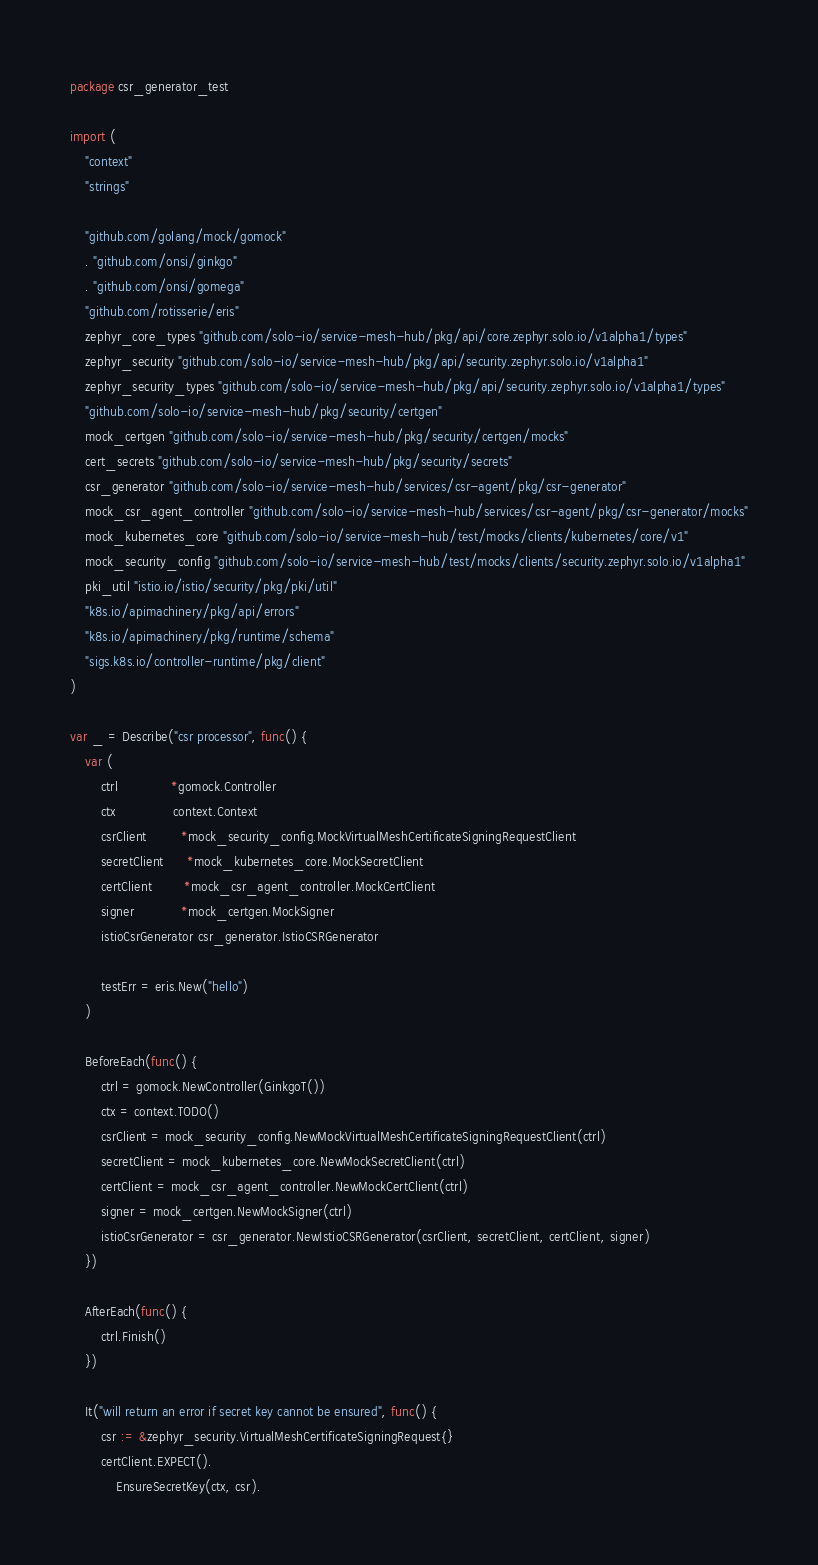Convert code to text. <code><loc_0><loc_0><loc_500><loc_500><_Go_>package csr_generator_test

import (
	"context"
	"strings"

	"github.com/golang/mock/gomock"
	. "github.com/onsi/ginkgo"
	. "github.com/onsi/gomega"
	"github.com/rotisserie/eris"
	zephyr_core_types "github.com/solo-io/service-mesh-hub/pkg/api/core.zephyr.solo.io/v1alpha1/types"
	zephyr_security "github.com/solo-io/service-mesh-hub/pkg/api/security.zephyr.solo.io/v1alpha1"
	zephyr_security_types "github.com/solo-io/service-mesh-hub/pkg/api/security.zephyr.solo.io/v1alpha1/types"
	"github.com/solo-io/service-mesh-hub/pkg/security/certgen"
	mock_certgen "github.com/solo-io/service-mesh-hub/pkg/security/certgen/mocks"
	cert_secrets "github.com/solo-io/service-mesh-hub/pkg/security/secrets"
	csr_generator "github.com/solo-io/service-mesh-hub/services/csr-agent/pkg/csr-generator"
	mock_csr_agent_controller "github.com/solo-io/service-mesh-hub/services/csr-agent/pkg/csr-generator/mocks"
	mock_kubernetes_core "github.com/solo-io/service-mesh-hub/test/mocks/clients/kubernetes/core/v1"
	mock_security_config "github.com/solo-io/service-mesh-hub/test/mocks/clients/security.zephyr.solo.io/v1alpha1"
	pki_util "istio.io/istio/security/pkg/pki/util"
	"k8s.io/apimachinery/pkg/api/errors"
	"k8s.io/apimachinery/pkg/runtime/schema"
	"sigs.k8s.io/controller-runtime/pkg/client"
)

var _ = Describe("csr processor", func() {
	var (
		ctrl              *gomock.Controller
		ctx               context.Context
		csrClient         *mock_security_config.MockVirtualMeshCertificateSigningRequestClient
		secretClient      *mock_kubernetes_core.MockSecretClient
		certClient        *mock_csr_agent_controller.MockCertClient
		signer            *mock_certgen.MockSigner
		istioCsrGenerator csr_generator.IstioCSRGenerator

		testErr = eris.New("hello")
	)

	BeforeEach(func() {
		ctrl = gomock.NewController(GinkgoT())
		ctx = context.TODO()
		csrClient = mock_security_config.NewMockVirtualMeshCertificateSigningRequestClient(ctrl)
		secretClient = mock_kubernetes_core.NewMockSecretClient(ctrl)
		certClient = mock_csr_agent_controller.NewMockCertClient(ctrl)
		signer = mock_certgen.NewMockSigner(ctrl)
		istioCsrGenerator = csr_generator.NewIstioCSRGenerator(csrClient, secretClient, certClient, signer)
	})

	AfterEach(func() {
		ctrl.Finish()
	})

	It("will return an error if secret key cannot be ensured", func() {
		csr := &zephyr_security.VirtualMeshCertificateSigningRequest{}
		certClient.EXPECT().
			EnsureSecretKey(ctx, csr).</code> 